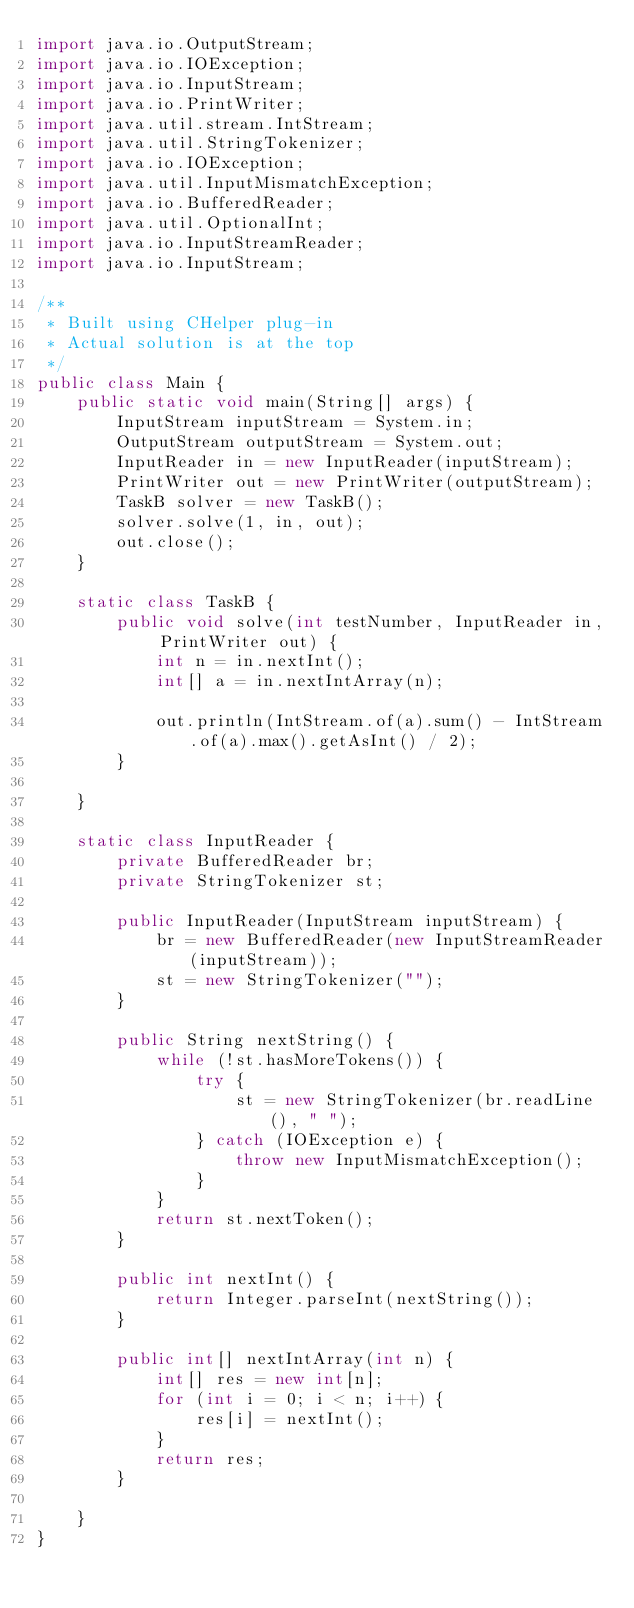<code> <loc_0><loc_0><loc_500><loc_500><_Java_>import java.io.OutputStream;
import java.io.IOException;
import java.io.InputStream;
import java.io.PrintWriter;
import java.util.stream.IntStream;
import java.util.StringTokenizer;
import java.io.IOException;
import java.util.InputMismatchException;
import java.io.BufferedReader;
import java.util.OptionalInt;
import java.io.InputStreamReader;
import java.io.InputStream;

/**
 * Built using CHelper plug-in
 * Actual solution is at the top
 */
public class Main {
    public static void main(String[] args) {
        InputStream inputStream = System.in;
        OutputStream outputStream = System.out;
        InputReader in = new InputReader(inputStream);
        PrintWriter out = new PrintWriter(outputStream);
        TaskB solver = new TaskB();
        solver.solve(1, in, out);
        out.close();
    }

    static class TaskB {
        public void solve(int testNumber, InputReader in, PrintWriter out) {
            int n = in.nextInt();
            int[] a = in.nextIntArray(n);

            out.println(IntStream.of(a).sum() - IntStream.of(a).max().getAsInt() / 2);
        }

    }

    static class InputReader {
        private BufferedReader br;
        private StringTokenizer st;

        public InputReader(InputStream inputStream) {
            br = new BufferedReader(new InputStreamReader(inputStream));
            st = new StringTokenizer("");
        }

        public String nextString() {
            while (!st.hasMoreTokens()) {
                try {
                    st = new StringTokenizer(br.readLine(), " ");
                } catch (IOException e) {
                    throw new InputMismatchException();
                }
            }
            return st.nextToken();
        }

        public int nextInt() {
            return Integer.parseInt(nextString());
        }

        public int[] nextIntArray(int n) {
            int[] res = new int[n];
            for (int i = 0; i < n; i++) {
                res[i] = nextInt();
            }
            return res;
        }

    }
}

</code> 